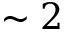<formula> <loc_0><loc_0><loc_500><loc_500>\sim 2</formula> 